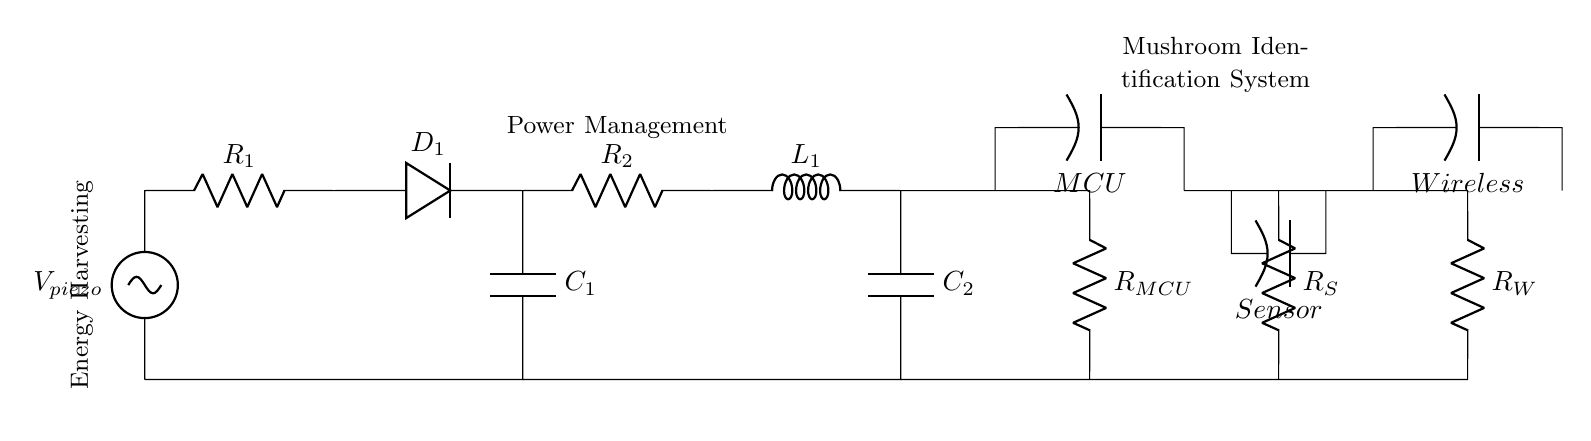What type of voltage source is used in this circuit? The circuit uses a piezoelectric voltage source indicated by the label "V_piezo". Piezoelectric sources convert mechanical stress into electrical voltage.
Answer: piezoelectric What is the role of component D1? D1 is a diode that allows current to flow in one direction, preventing reverse current, which is essential for charging the capacitor from the piezo voltage source.
Answer: rectification How many capacitors are present in the circuit? The circuit contains two capacitors, labeled C1 and C2, used for storing energy harvested from the piezoelectric source and smoothing the voltage respectively.
Answer: two What is the purpose of R2 in this circuit? R2 is a resistor that is part of the power management section, which helps to control the current flowing to the microcontroller and other components, ensuring they receive stable power levels.
Answer: current regulation What component connects the sensor to the power circuit? The sensor is connected to the power circuit via a resistor labeled R_S, which limits current and protects the sensor from excessive voltage.
Answer: resistor What does the notation "MCU" represent in the circuit? The notation "MCU" stands for Microcontroller Unit, indicating the component that processes data from the sensor and manages the overall operation of the wearable device.
Answer: Microcontroller 